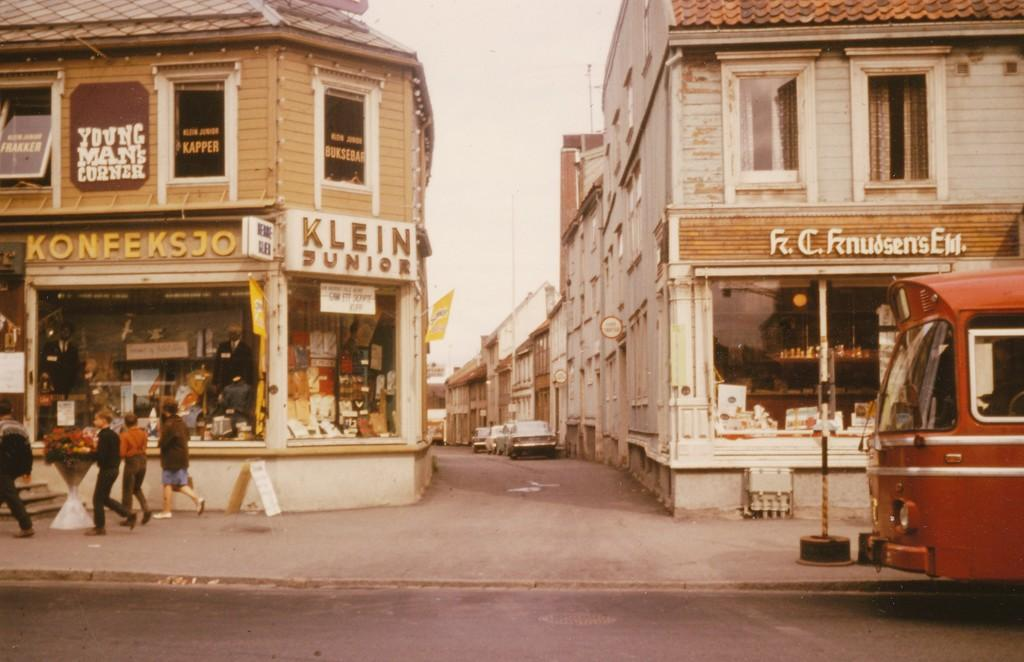What type of structures can be seen in the image? There are buildings in the image. What additional objects are present in the image? There are banners, boards, vehicles, people, flowers, and poles in the image. What is the primary mode of transportation visible in the image? Vehicles are visible in the image. What can be seen in the background of the image? The sky is visible in the background of the image. Where is the boy sitting on the sofa in the image? There is no boy or sofa present in the image. What type of building is shown in the image? The provided facts do not specify the type of building; they only mention that there are buildings in the image. 